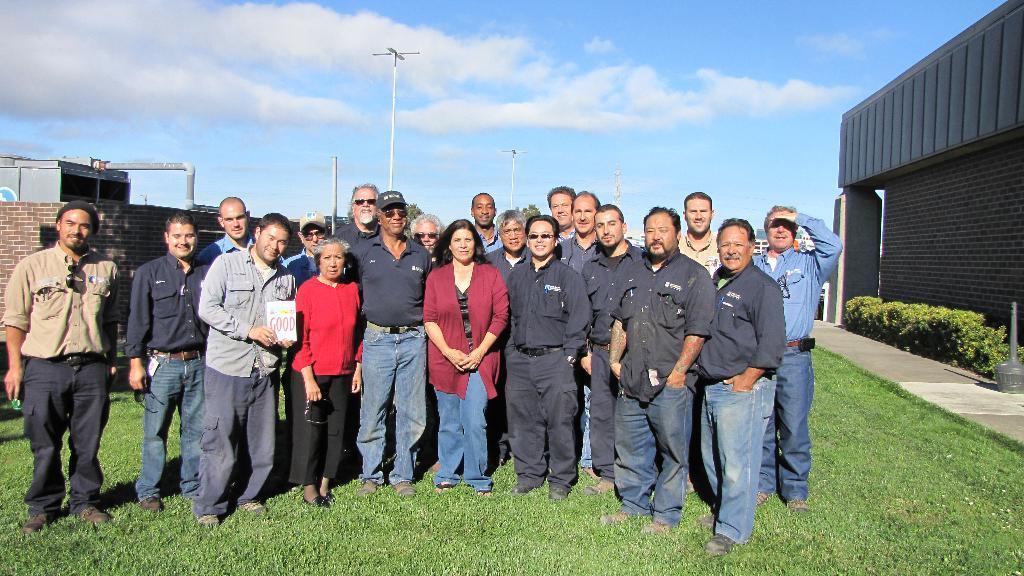Please provide a concise description of this image. In this picture we can see a group of people on the ground and in the background we can see buildings,poles,sky. 